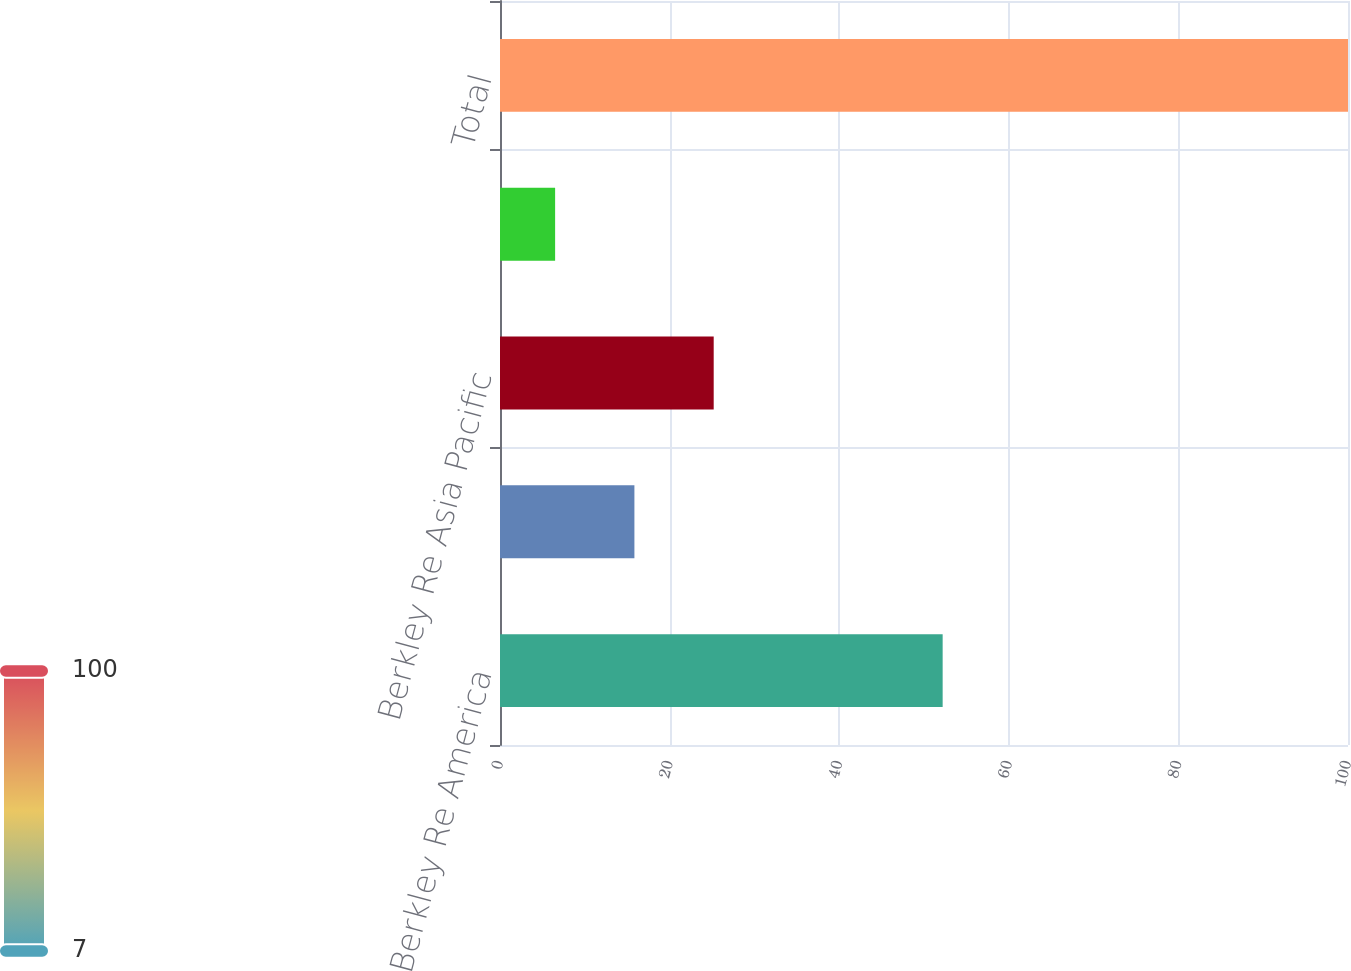<chart> <loc_0><loc_0><loc_500><loc_500><bar_chart><fcel>Berkley Re America<fcel>Berkley Re UK<fcel>Berkley Re Asia Pacific<fcel>Berkley Re Direct<fcel>Total<nl><fcel>52.2<fcel>15.85<fcel>25.2<fcel>6.5<fcel>100<nl></chart> 